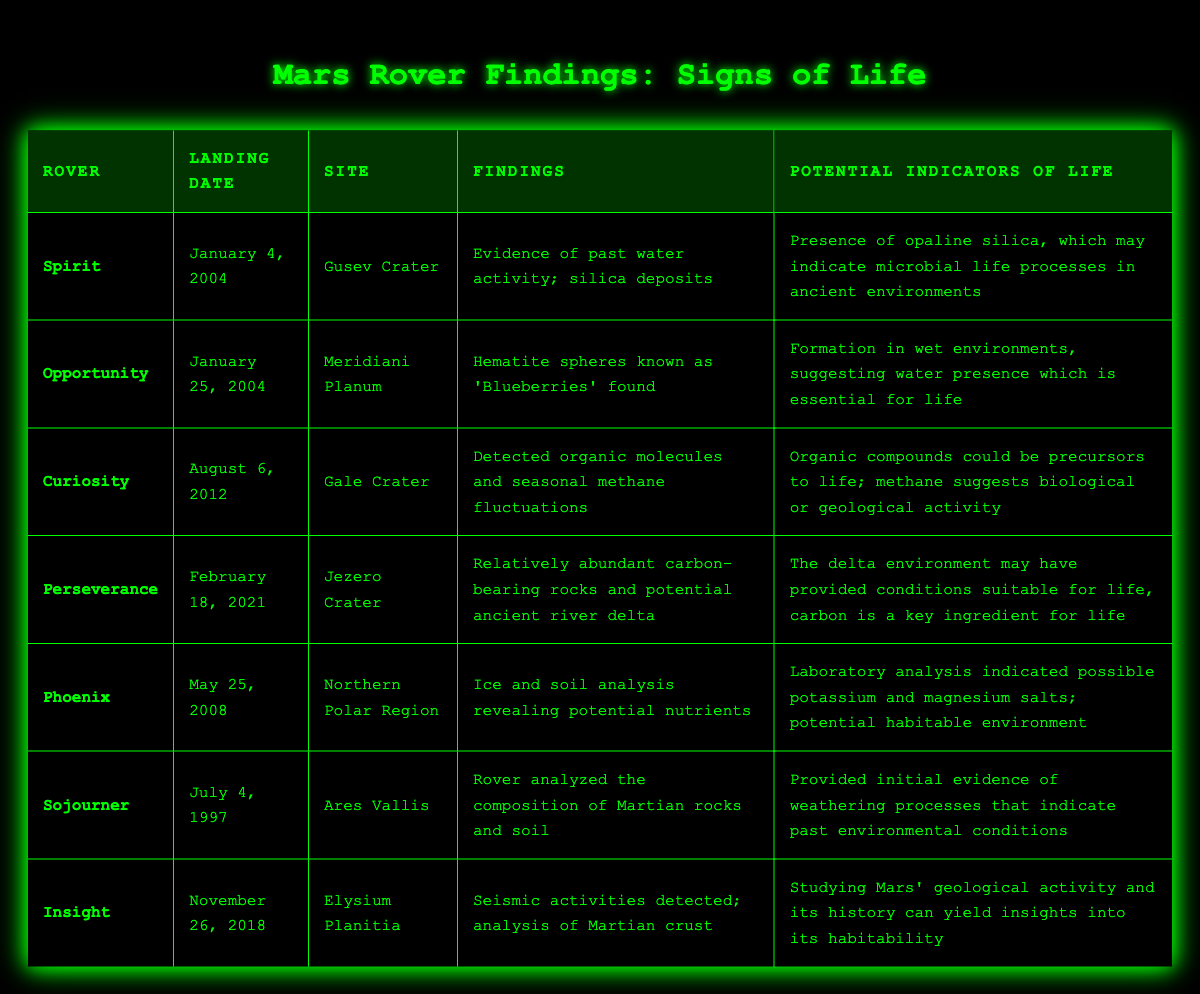What rover landed on January 4, 2004? Referring to the table, the rover listed with the landing date of January 4, 2004, is Spirit.
Answer: Spirit Which rover found evidence of organic molecules? According to the table, Curiosity is the rover that detected organic molecules.
Answer: Curiosity What site did the Opportunity rover land on? The table shows that the Opportunity rover landed on Meridiani Planum.
Answer: Meridiani Planum Was ice detected by the Phoenix rover? The table indicates that Phoenix performed ice and soil analysis, suggesting that ice was indeed detected.
Answer: Yes Which rover's findings indicated the presence of past water activity? The table states that the Spirit rover provided evidence of past water activity.
Answer: Spirit How many rovers landed in 2004? The table lists two rovers, Spirit and Opportunity, that landed in 2004.
Answer: 2 Which rover analyzed the composition of Martian rocks and soil? According to the table, Sojourner is the rover that analyzed the composition of Martian rocks and soil.
Answer: Sojourner What insights could be gained from the seismic activities detected by Insight? The table suggests that studying Mars's geological activity through Insight's findings can yield insights into its habitability.
Answer: Insights into habitability Which rover found potential habitable conditions based on carbon presence? The Perseverance rover is noted in the table for finding relatively abundant carbon-bearing rocks, suggesting potential habitable conditions.
Answer: Perseverance What is the primary finding of the Curiosity rover regarding methane? The table reveals that Curiosity detected seasonal methane fluctuations, which could indicate biological or geological activity.
Answer: Seasonal methane fluctuations How does the findings of the Opportunity rover relate to the presence of water? The findings regarding hematite spheres ('Blueberries') suggest that they formed in wet environments, indicating the past presence of water essential for life.
Answer: They indicate past water presence What potential indicators of life were found in the Gusev Crater? According to the table, the presence of opaline silica in Gusev Crater may indicate microbial life processes in ancient environments.
Answer: Opaline silica Which rover had findings that suggested the conditions suitable for life based on a delta environment? The table indicates that Perseverance found carbon-bearing rocks in a potential ancient river delta, suggesting suitable conditions for life.
Answer: Perseverance 